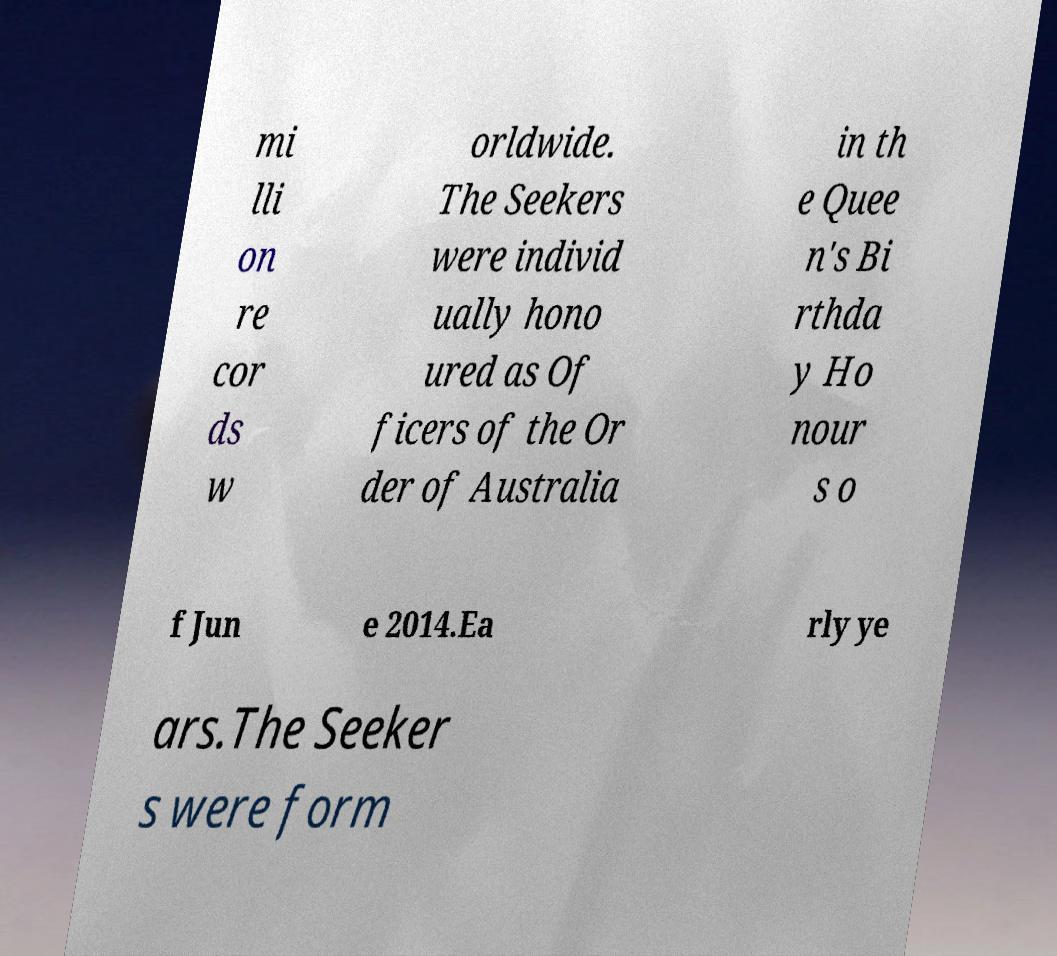For documentation purposes, I need the text within this image transcribed. Could you provide that? mi lli on re cor ds w orldwide. The Seekers were individ ually hono ured as Of ficers of the Or der of Australia in th e Quee n's Bi rthda y Ho nour s o f Jun e 2014.Ea rly ye ars.The Seeker s were form 